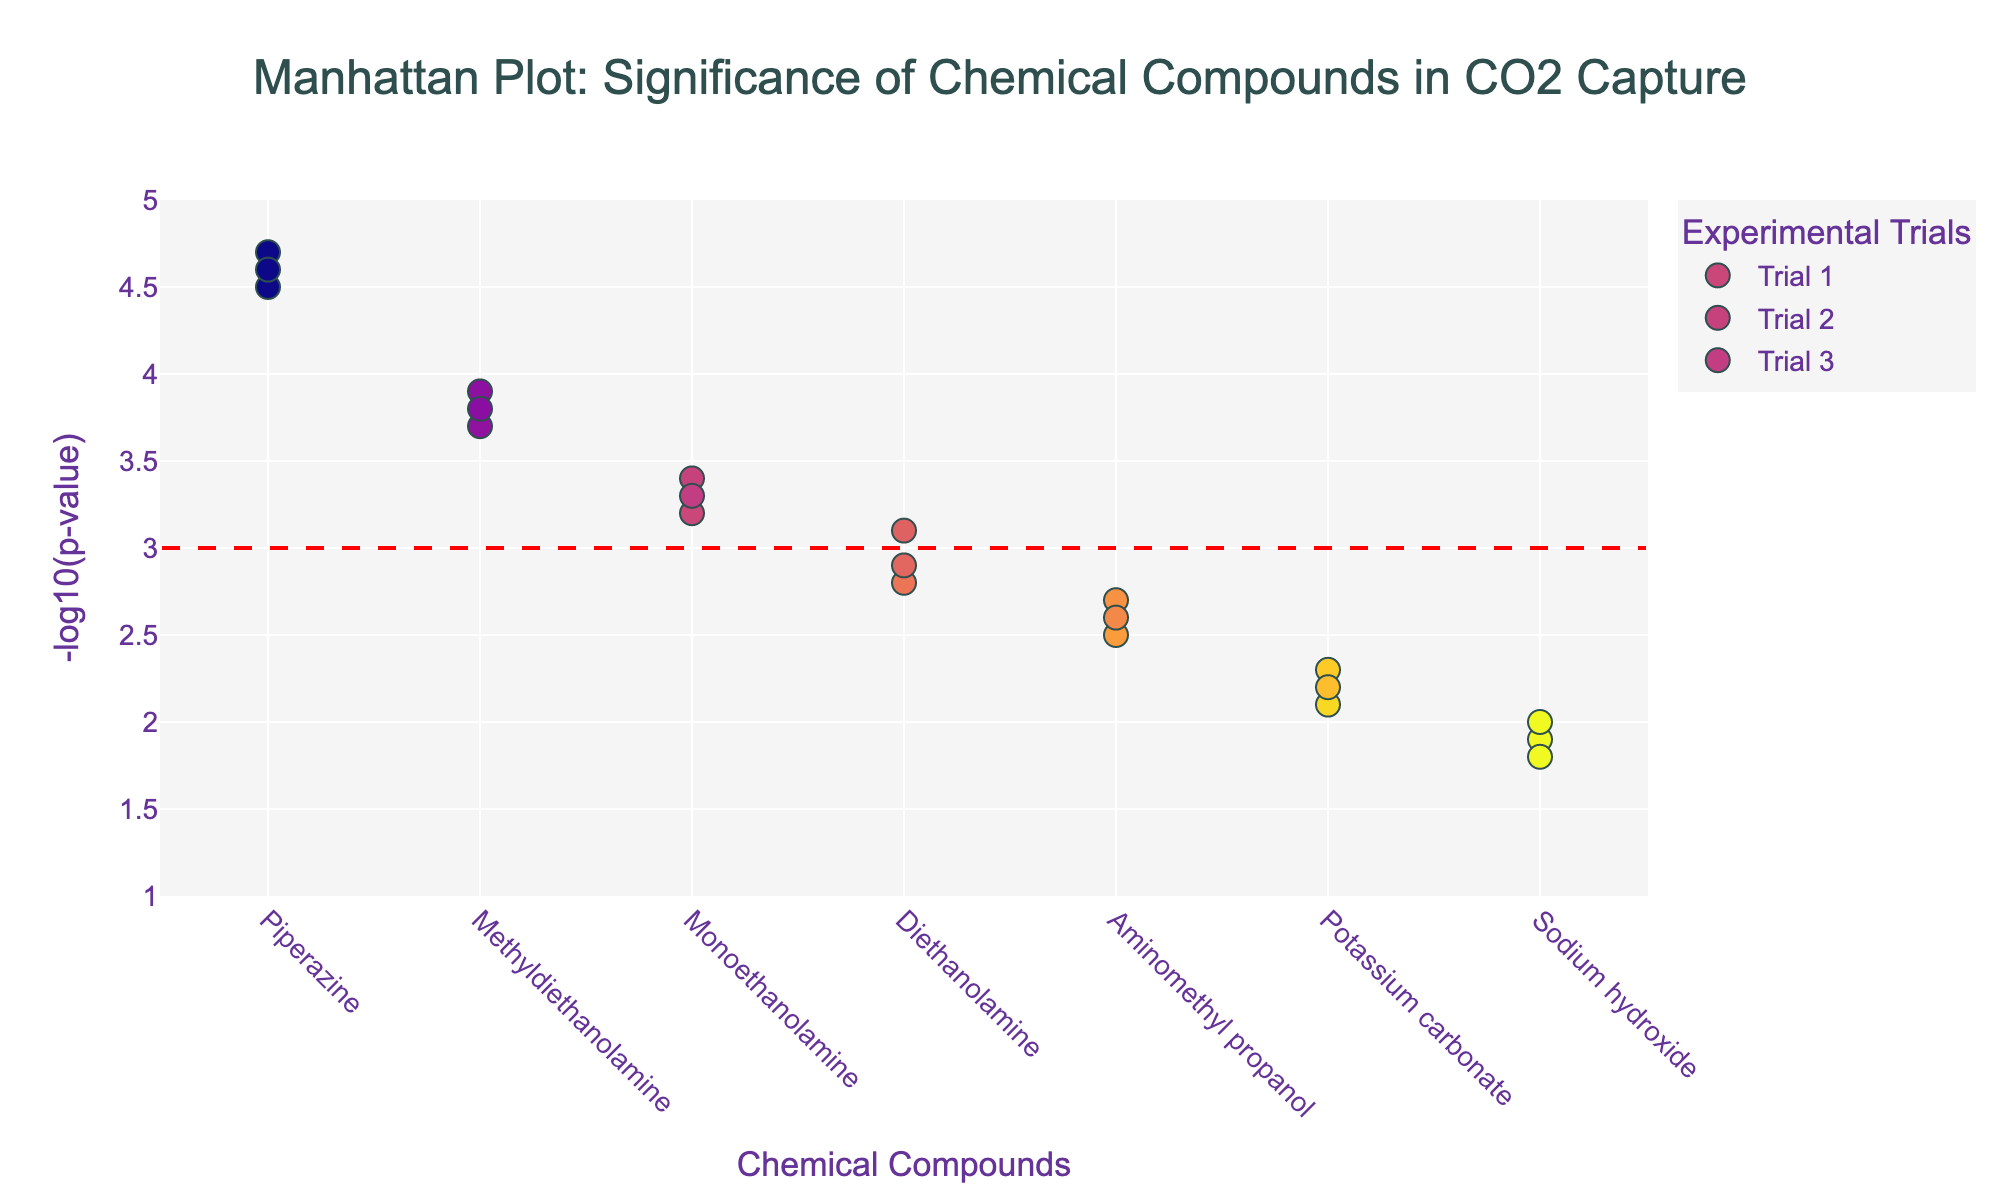What is the title of the figure? The title is usually prominently displayed at the top of the figure. In this case, it states: "Manhattan Plot: Significance of Chemical Compounds in CO2 Capture"
Answer: Manhattan Plot: Significance of Chemical Compounds in CO2 Capture How many trials are represented in the figure? The figure shows markers with different labels for each trial. Each trial is named and depicted separately in the legend and plot. Counting these labels, we find there are 3 trials: Trial 1, Trial 2, and Trial 3.
Answer: 3 Which chemical compound has the highest average significance across all trials? First, identify the compounds with the highest points on the y-axis in each trial. According to the data, Piperazine has the highest average NegativeLogPValue across all trials (4.5, 4.7, 4.6 = avg 4.6). The compound with the highest average significance is Piperazine.
Answer: Piperazine Is any compound’s average significance above the threshold line at y=3? Locate the horizontal red dash line at y=3 and check which compounds have markers above this line in the majority of trials. Compounds like Monoethanolamine, Piperazine, Methyldiethanolamine are above the threshold line most of the time.
Answer: Yes Which trial has the highest significance value for Methyldiethanolamine? Plot markers for Methyldiethanolamine are found for each trial. By comparing the y-values, the highest point is in Trial 2 with a NegativeLogPValue of 3.9.
Answer: Trial 2 What is the general trend of significance across trials for Sodium hydroxide? Analyze the points for Sodium hydroxide across the trials on the y-axis. The values are 1.9, 2.0, and 1.8, respectively. There is no clear trend; it remains relatively low and consistent.
Answer: Consistently low Which trial had the least significance for Potassium carbonate? Observe the Potassium carbonate markers in each trial. The lowest value (2.1) appears in Trial 1. The values are higher in other trials.
Answer: Trial 1 Calculate the average significance of Diethanolamine across the trials. Diethanolamine has values of 2.8, 3.1, and 2.9 respectively. Calculate the average by summing these values and dividing by 3: (2.8 + 3.1 + 2.9) / 3 = 2.93.
Answer: 2.93 